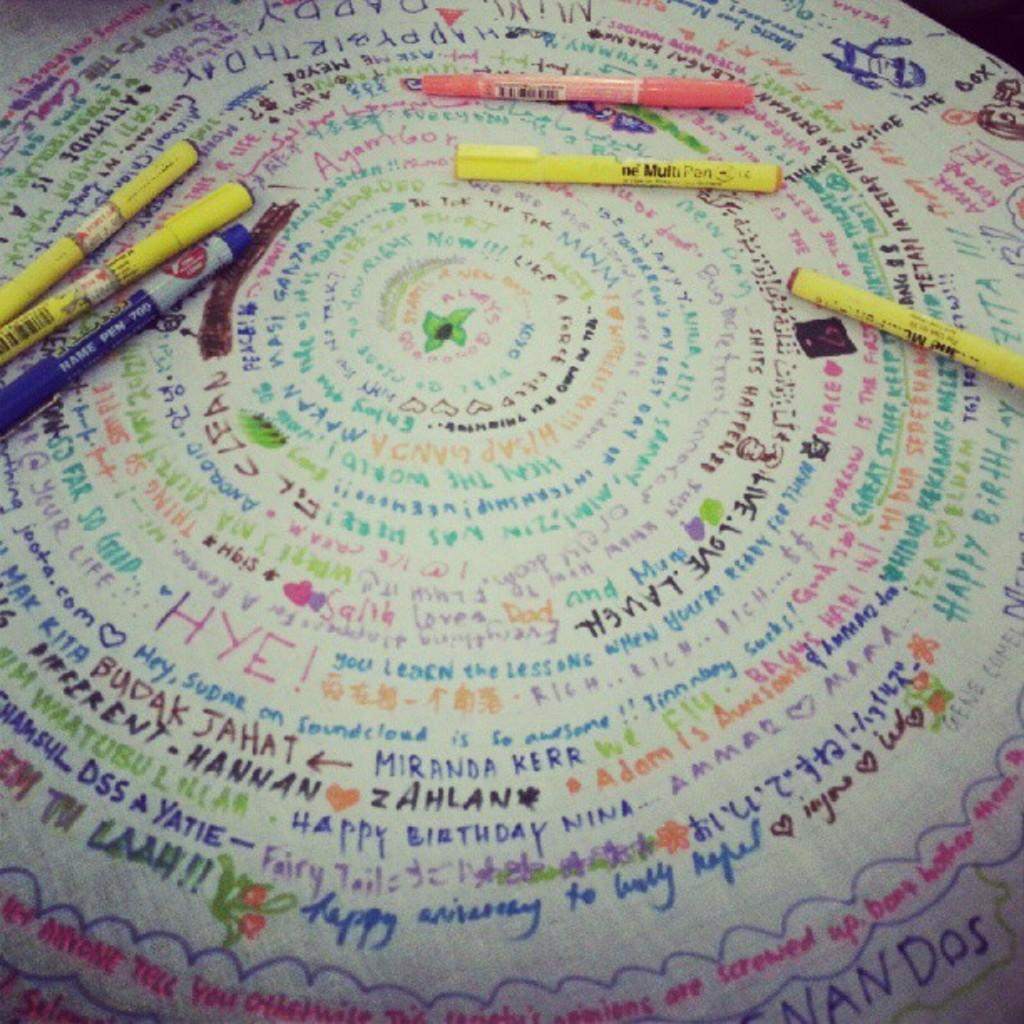What is the main object in the image? There is a board in the image. What is placed on the board? There are pens on the board. What can be seen written on the board? There are texts written on the board. What type of sugar is being used to write on the board? There is no sugar present in the image, and it is not being used to write on the board. 